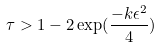<formula> <loc_0><loc_0><loc_500><loc_500>\tau > 1 - 2 \exp ( \frac { - k \epsilon ^ { 2 } } { 4 } )</formula> 